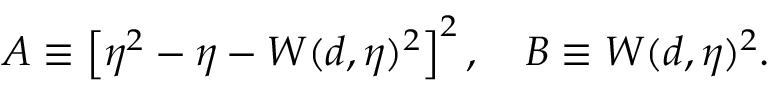<formula> <loc_0><loc_0><loc_500><loc_500>A \equiv \left [ \eta ^ { 2 } - \eta - W ( d , \eta ) ^ { 2 } \right ] ^ { 2 } , \quad B \equiv W ( d , \eta ) ^ { 2 } .</formula> 